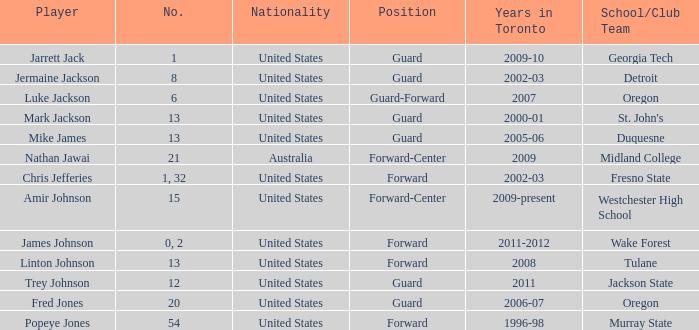During the 2006-07 season, what was the overall number of positions on the toronto team? 1.0. 